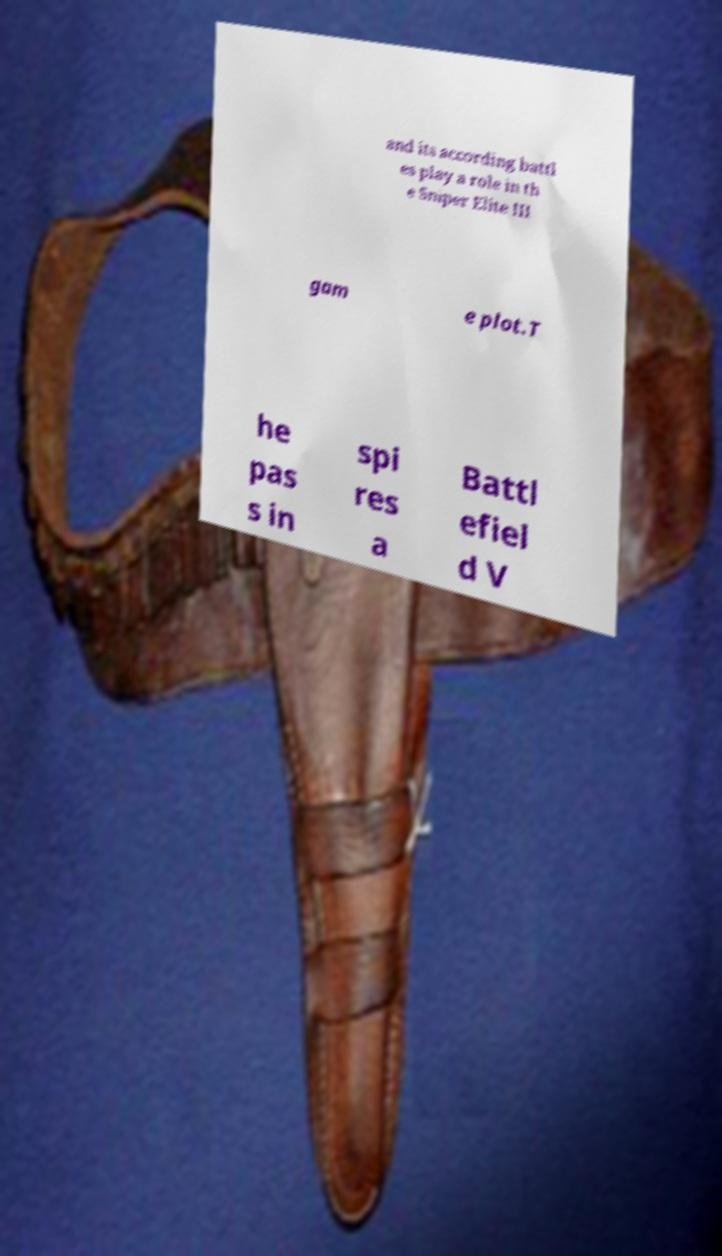Please identify and transcribe the text found in this image. and its according battl es play a role in th e Sniper Elite III gam e plot.T he pas s in spi res a Battl efiel d V 